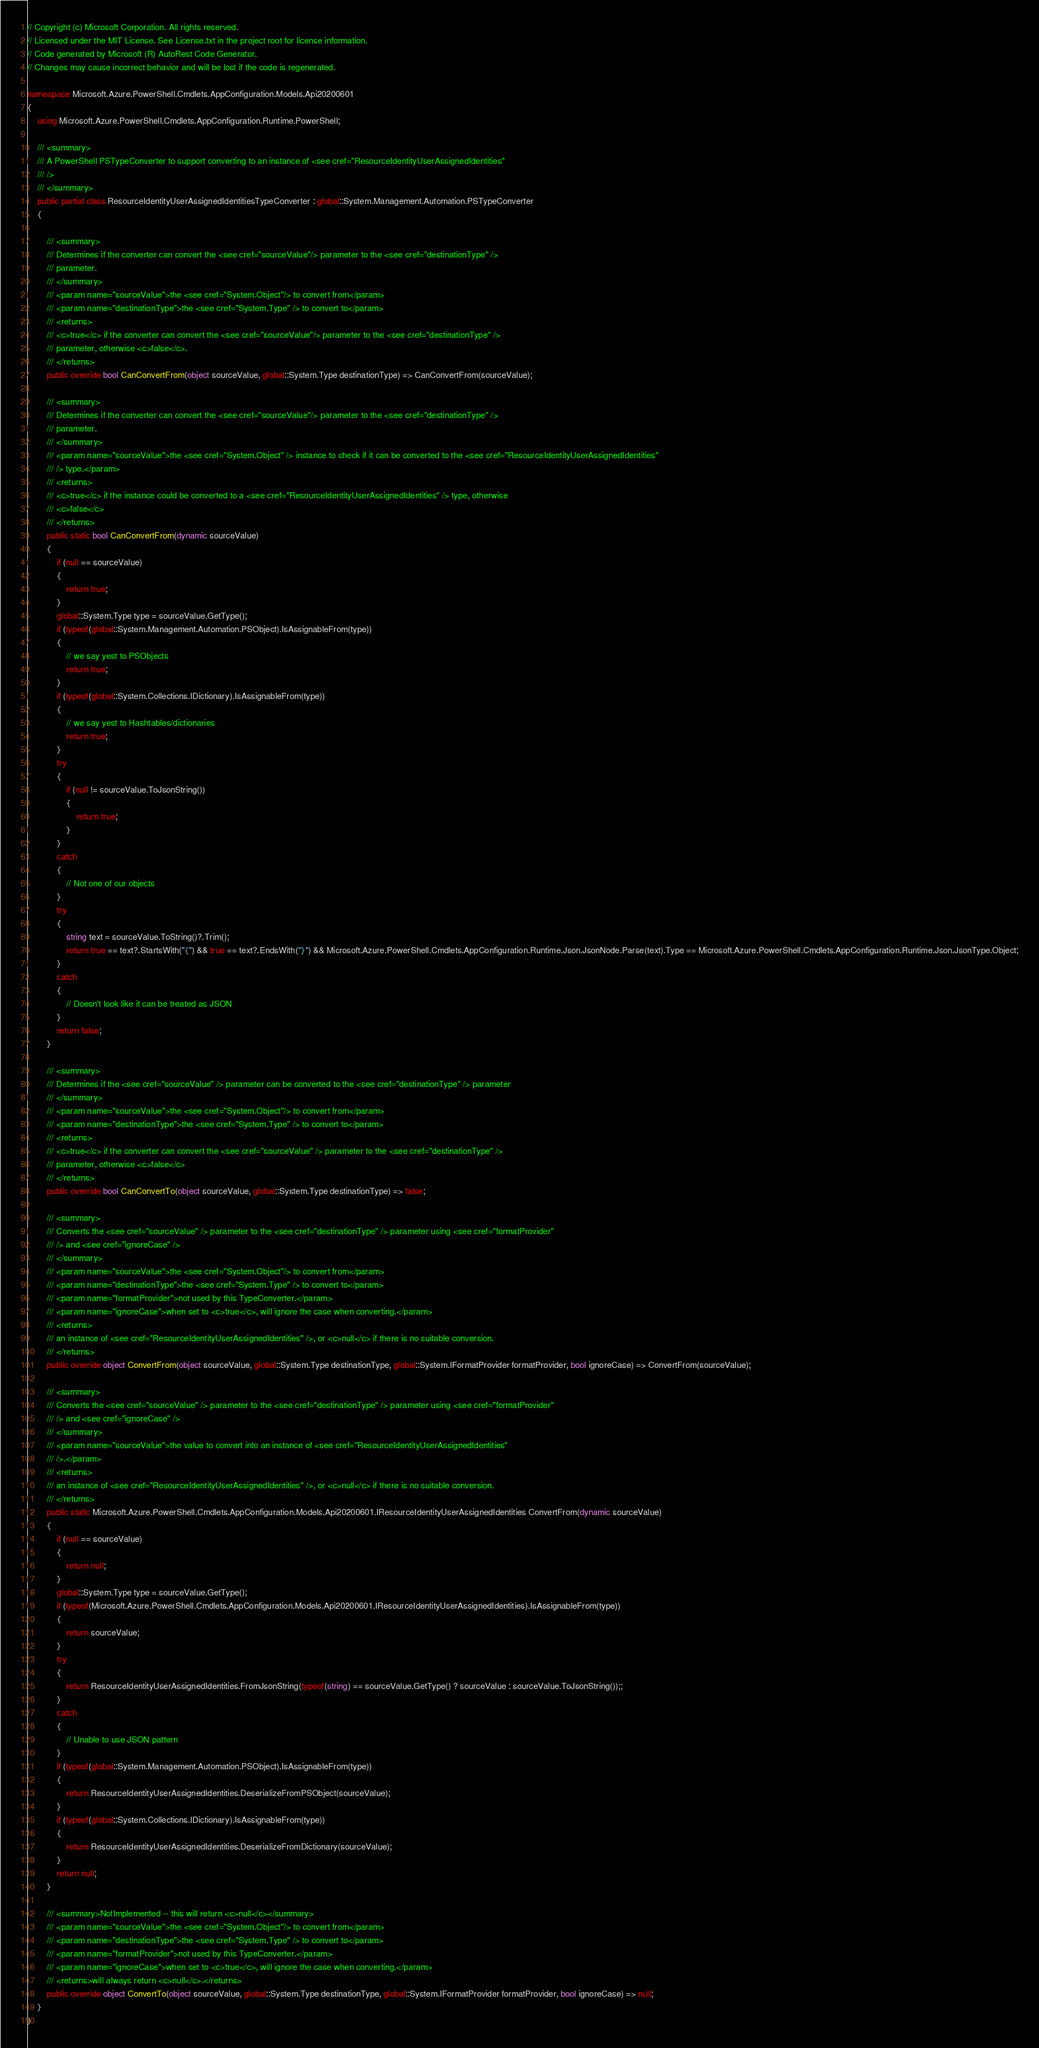Convert code to text. <code><loc_0><loc_0><loc_500><loc_500><_C#_>// Copyright (c) Microsoft Corporation. All rights reserved.
// Licensed under the MIT License. See License.txt in the project root for license information.
// Code generated by Microsoft (R) AutoRest Code Generator.
// Changes may cause incorrect behavior and will be lost if the code is regenerated.

namespace Microsoft.Azure.PowerShell.Cmdlets.AppConfiguration.Models.Api20200601
{
    using Microsoft.Azure.PowerShell.Cmdlets.AppConfiguration.Runtime.PowerShell;

    /// <summary>
    /// A PowerShell PSTypeConverter to support converting to an instance of <see cref="ResourceIdentityUserAssignedIdentities"
    /// />
    /// </summary>
    public partial class ResourceIdentityUserAssignedIdentitiesTypeConverter : global::System.Management.Automation.PSTypeConverter
    {

        /// <summary>
        /// Determines if the converter can convert the <see cref="sourceValue"/> parameter to the <see cref="destinationType" />
        /// parameter.
        /// </summary>
        /// <param name="sourceValue">the <see cref="System.Object"/> to convert from</param>
        /// <param name="destinationType">the <see cref="System.Type" /> to convert to</param>
        /// <returns>
        /// <c>true</c> if the converter can convert the <see cref="sourceValue"/> parameter to the <see cref="destinationType" />
        /// parameter, otherwise <c>false</c>.
        /// </returns>
        public override bool CanConvertFrom(object sourceValue, global::System.Type destinationType) => CanConvertFrom(sourceValue);

        /// <summary>
        /// Determines if the converter can convert the <see cref="sourceValue"/> parameter to the <see cref="destinationType" />
        /// parameter.
        /// </summary>
        /// <param name="sourceValue">the <see cref="System.Object" /> instance to check if it can be converted to the <see cref="ResourceIdentityUserAssignedIdentities"
        /// /> type.</param>
        /// <returns>
        /// <c>true</c> if the instance could be converted to a <see cref="ResourceIdentityUserAssignedIdentities" /> type, otherwise
        /// <c>false</c>
        /// </returns>
        public static bool CanConvertFrom(dynamic sourceValue)
        {
            if (null == sourceValue)
            {
                return true;
            }
            global::System.Type type = sourceValue.GetType();
            if (typeof(global::System.Management.Automation.PSObject).IsAssignableFrom(type))
            {
                // we say yest to PSObjects
                return true;
            }
            if (typeof(global::System.Collections.IDictionary).IsAssignableFrom(type))
            {
                // we say yest to Hashtables/dictionaries
                return true;
            }
            try
            {
                if (null != sourceValue.ToJsonString())
                {
                    return true;
                }
            }
            catch
            {
                // Not one of our objects
            }
            try
            {
                string text = sourceValue.ToString()?.Trim();
                return true == text?.StartsWith("{") && true == text?.EndsWith("}") && Microsoft.Azure.PowerShell.Cmdlets.AppConfiguration.Runtime.Json.JsonNode.Parse(text).Type == Microsoft.Azure.PowerShell.Cmdlets.AppConfiguration.Runtime.Json.JsonType.Object;
            }
            catch
            {
                // Doesn't look like it can be treated as JSON
            }
            return false;
        }

        /// <summary>
        /// Determines if the <see cref="sourceValue" /> parameter can be converted to the <see cref="destinationType" /> parameter
        /// </summary>
        /// <param name="sourceValue">the <see cref="System.Object"/> to convert from</param>
        /// <param name="destinationType">the <see cref="System.Type" /> to convert to</param>
        /// <returns>
        /// <c>true</c> if the converter can convert the <see cref="sourceValue" /> parameter to the <see cref="destinationType" />
        /// parameter, otherwise <c>false</c>
        /// </returns>
        public override bool CanConvertTo(object sourceValue, global::System.Type destinationType) => false;

        /// <summary>
        /// Converts the <see cref="sourceValue" /> parameter to the <see cref="destinationType" /> parameter using <see cref="formatProvider"
        /// /> and <see cref="ignoreCase" />
        /// </summary>
        /// <param name="sourceValue">the <see cref="System.Object"/> to convert from</param>
        /// <param name="destinationType">the <see cref="System.Type" /> to convert to</param>
        /// <param name="formatProvider">not used by this TypeConverter.</param>
        /// <param name="ignoreCase">when set to <c>true</c>, will ignore the case when converting.</param>
        /// <returns>
        /// an instance of <see cref="ResourceIdentityUserAssignedIdentities" />, or <c>null</c> if there is no suitable conversion.
        /// </returns>
        public override object ConvertFrom(object sourceValue, global::System.Type destinationType, global::System.IFormatProvider formatProvider, bool ignoreCase) => ConvertFrom(sourceValue);

        /// <summary>
        /// Converts the <see cref="sourceValue" /> parameter to the <see cref="destinationType" /> parameter using <see cref="formatProvider"
        /// /> and <see cref="ignoreCase" />
        /// </summary>
        /// <param name="sourceValue">the value to convert into an instance of <see cref="ResourceIdentityUserAssignedIdentities"
        /// />.</param>
        /// <returns>
        /// an instance of <see cref="ResourceIdentityUserAssignedIdentities" />, or <c>null</c> if there is no suitable conversion.
        /// </returns>
        public static Microsoft.Azure.PowerShell.Cmdlets.AppConfiguration.Models.Api20200601.IResourceIdentityUserAssignedIdentities ConvertFrom(dynamic sourceValue)
        {
            if (null == sourceValue)
            {
                return null;
            }
            global::System.Type type = sourceValue.GetType();
            if (typeof(Microsoft.Azure.PowerShell.Cmdlets.AppConfiguration.Models.Api20200601.IResourceIdentityUserAssignedIdentities).IsAssignableFrom(type))
            {
                return sourceValue;
            }
            try
            {
                return ResourceIdentityUserAssignedIdentities.FromJsonString(typeof(string) == sourceValue.GetType() ? sourceValue : sourceValue.ToJsonString());;
            }
            catch
            {
                // Unable to use JSON pattern
            }
            if (typeof(global::System.Management.Automation.PSObject).IsAssignableFrom(type))
            {
                return ResourceIdentityUserAssignedIdentities.DeserializeFromPSObject(sourceValue);
            }
            if (typeof(global::System.Collections.IDictionary).IsAssignableFrom(type))
            {
                return ResourceIdentityUserAssignedIdentities.DeserializeFromDictionary(sourceValue);
            }
            return null;
        }

        /// <summary>NotImplemented -- this will return <c>null</c></summary>
        /// <param name="sourceValue">the <see cref="System.Object"/> to convert from</param>
        /// <param name="destinationType">the <see cref="System.Type" /> to convert to</param>
        /// <param name="formatProvider">not used by this TypeConverter.</param>
        /// <param name="ignoreCase">when set to <c>true</c>, will ignore the case when converting.</param>
        /// <returns>will always return <c>null</c>.</returns>
        public override object ConvertTo(object sourceValue, global::System.Type destinationType, global::System.IFormatProvider formatProvider, bool ignoreCase) => null;
    }
}</code> 